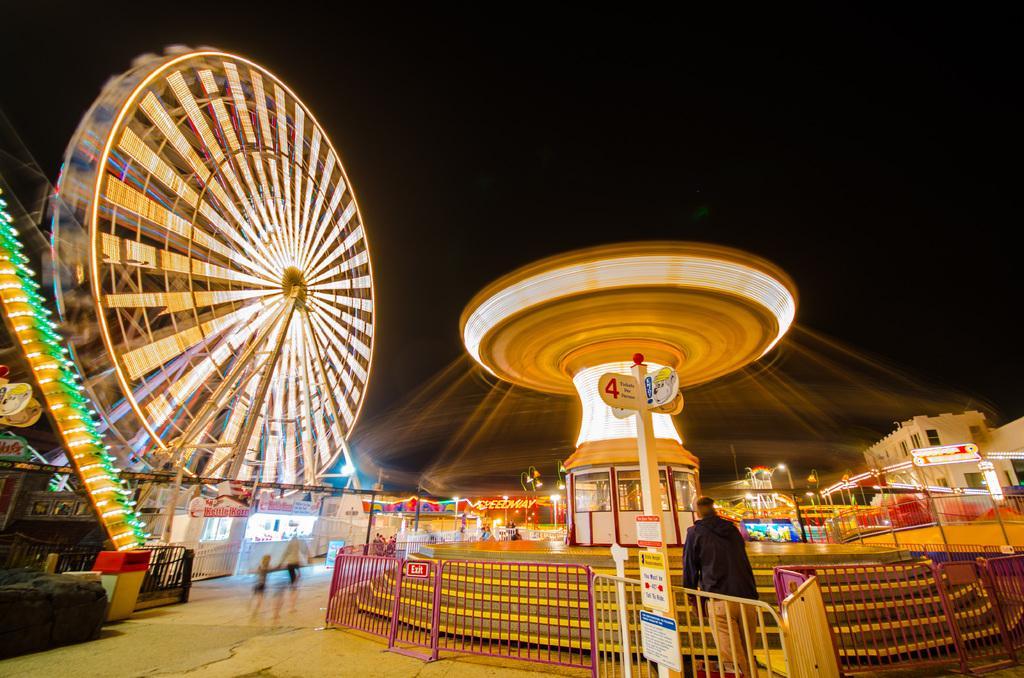How would you summarize this image in a sentence or two? In the image we can see exhibition. At the bottom of the image there is fencing. Behind the fencing a person is standing. In the middle of the image there is a pole, on the pole there are some sign boards. 